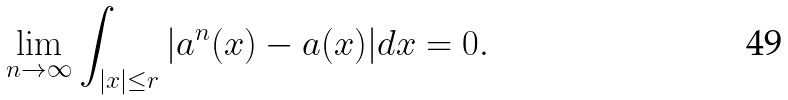<formula> <loc_0><loc_0><loc_500><loc_500>\lim _ { n \to \infty } \int _ { | x | \leq r } | a ^ { n } ( x ) - a ( x ) | d x = 0 .</formula> 